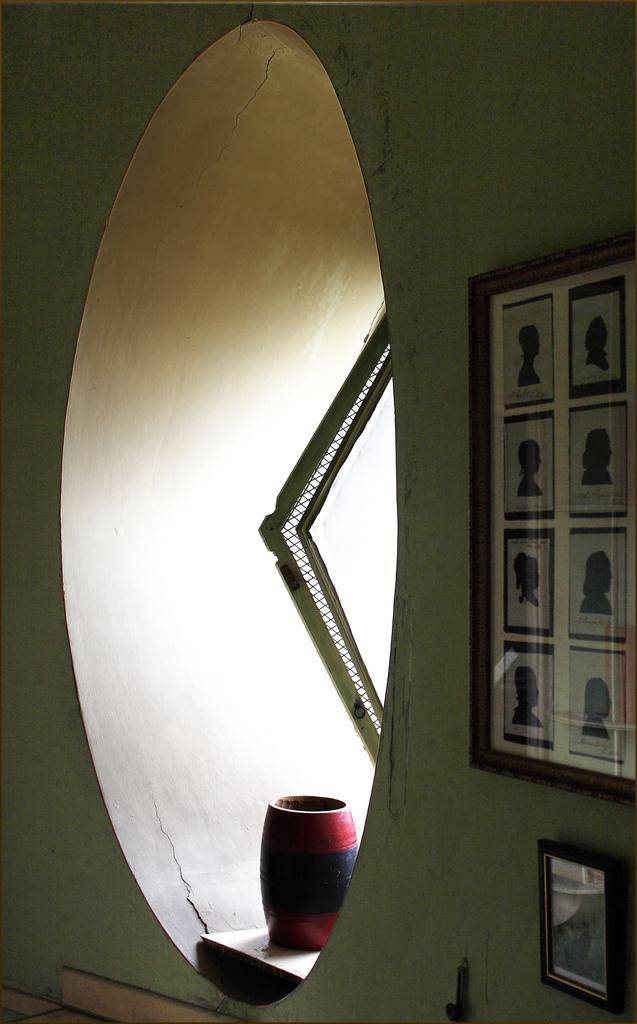What is on the wall in the image? There is a board and a mirror on the wall in the image. Can you describe the objects visible in the image? There are some objects visible in the image, but their specific details are not mentioned in the provided facts. What type of insurance policy is being discussed in the image? There is no indication in the image that an insurance policy is being discussed. How many pairs of feet are visible in the image? There is no mention of feet or any other body parts in the image. 